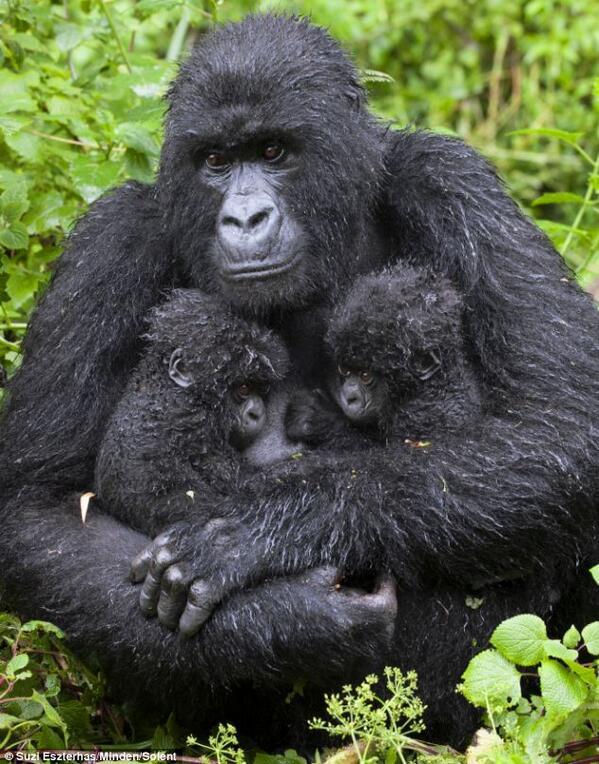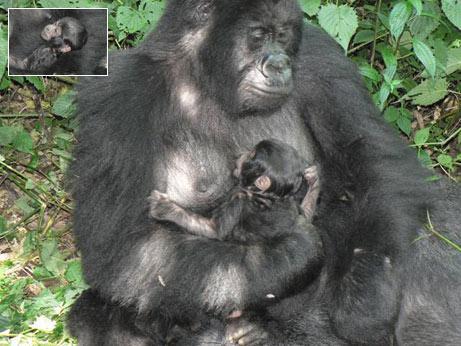The first image is the image on the left, the second image is the image on the right. Examine the images to the left and right. Is the description "Each image shows an upright adult gorilla with two baby gorillas in front of it, and at least one of the images shows the baby gorillas face-to-face and on the adult gorilla's chest." accurate? Answer yes or no. No. The first image is the image on the left, the second image is the image on the right. Examine the images to the left and right. Is the description "In each image, two baby gorillas are by their mother." accurate? Answer yes or no. No. 